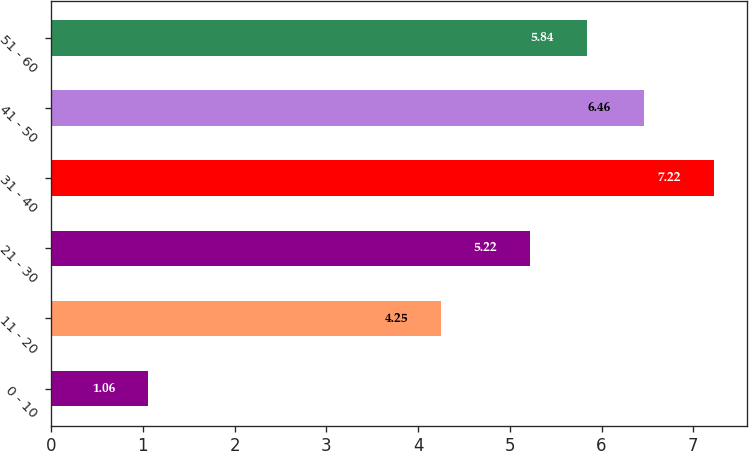<chart> <loc_0><loc_0><loc_500><loc_500><bar_chart><fcel>0 - 10<fcel>11 - 20<fcel>21 - 30<fcel>31 - 40<fcel>41 - 50<fcel>51 - 60<nl><fcel>1.06<fcel>4.25<fcel>5.22<fcel>7.22<fcel>6.46<fcel>5.84<nl></chart> 